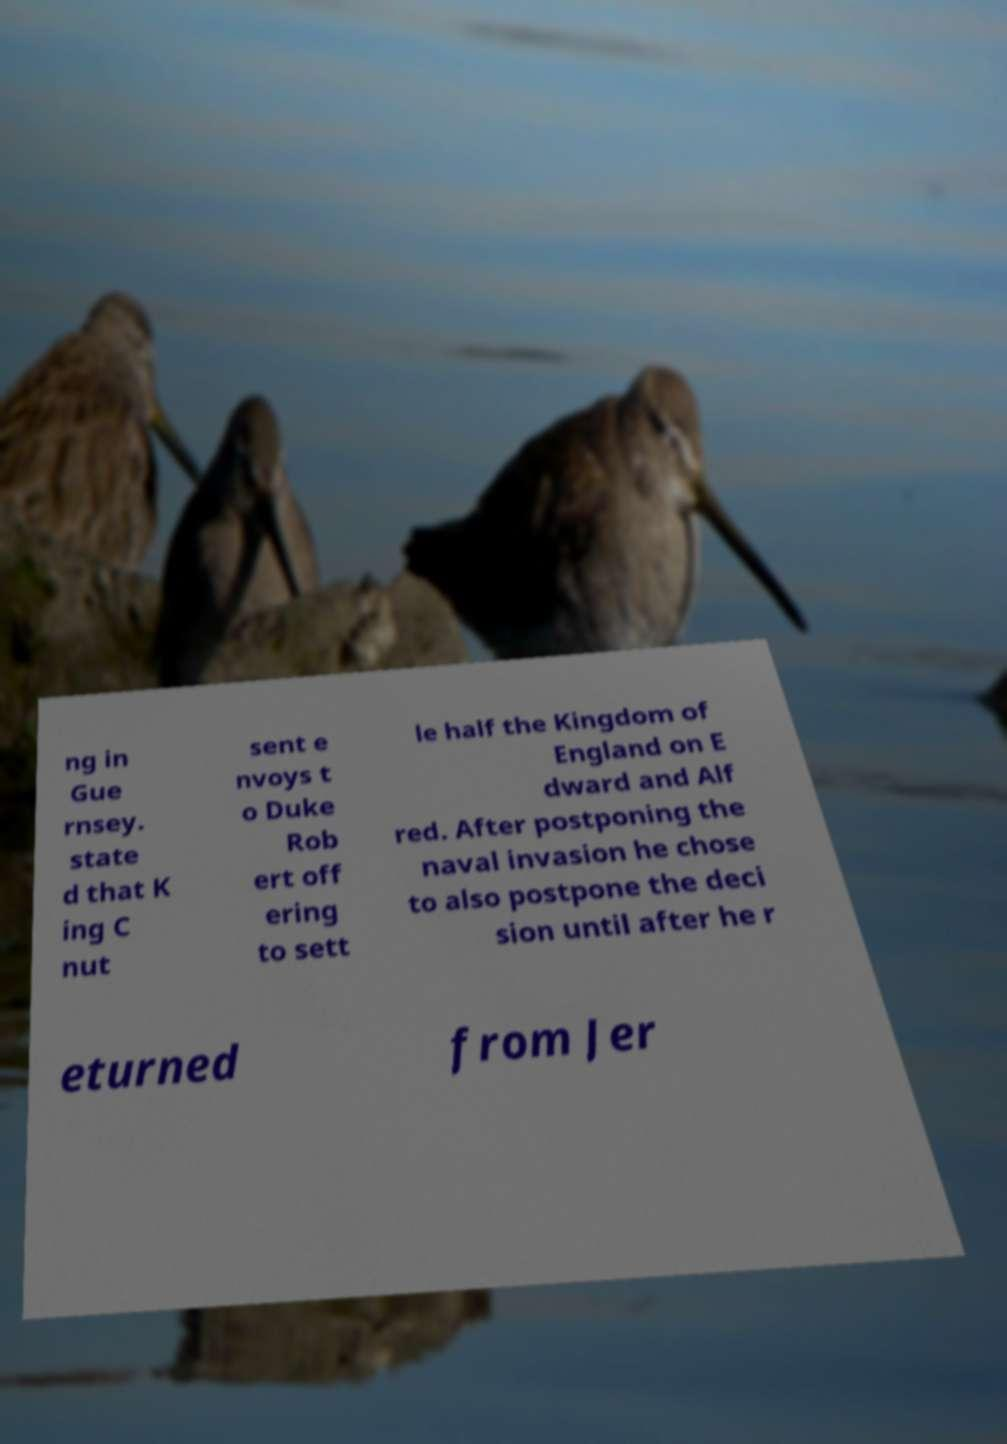I need the written content from this picture converted into text. Can you do that? ng in Gue rnsey. state d that K ing C nut sent e nvoys t o Duke Rob ert off ering to sett le half the Kingdom of England on E dward and Alf red. After postponing the naval invasion he chose to also postpone the deci sion until after he r eturned from Jer 